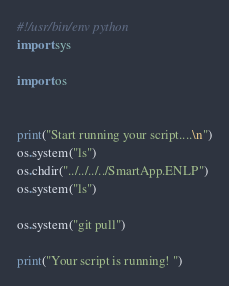<code> <loc_0><loc_0><loc_500><loc_500><_Python_>#!/usr/bin/env python
import sys

import os


print("Start running your script....\n")
os.system("ls")
os.chdir("../../../../SmartApp.ENLP")
os.system("ls")

os.system("git pull")

print("Your script is running! ")
</code> 